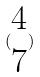<formula> <loc_0><loc_0><loc_500><loc_500>( \begin{matrix} 4 \\ 7 \end{matrix} )</formula> 